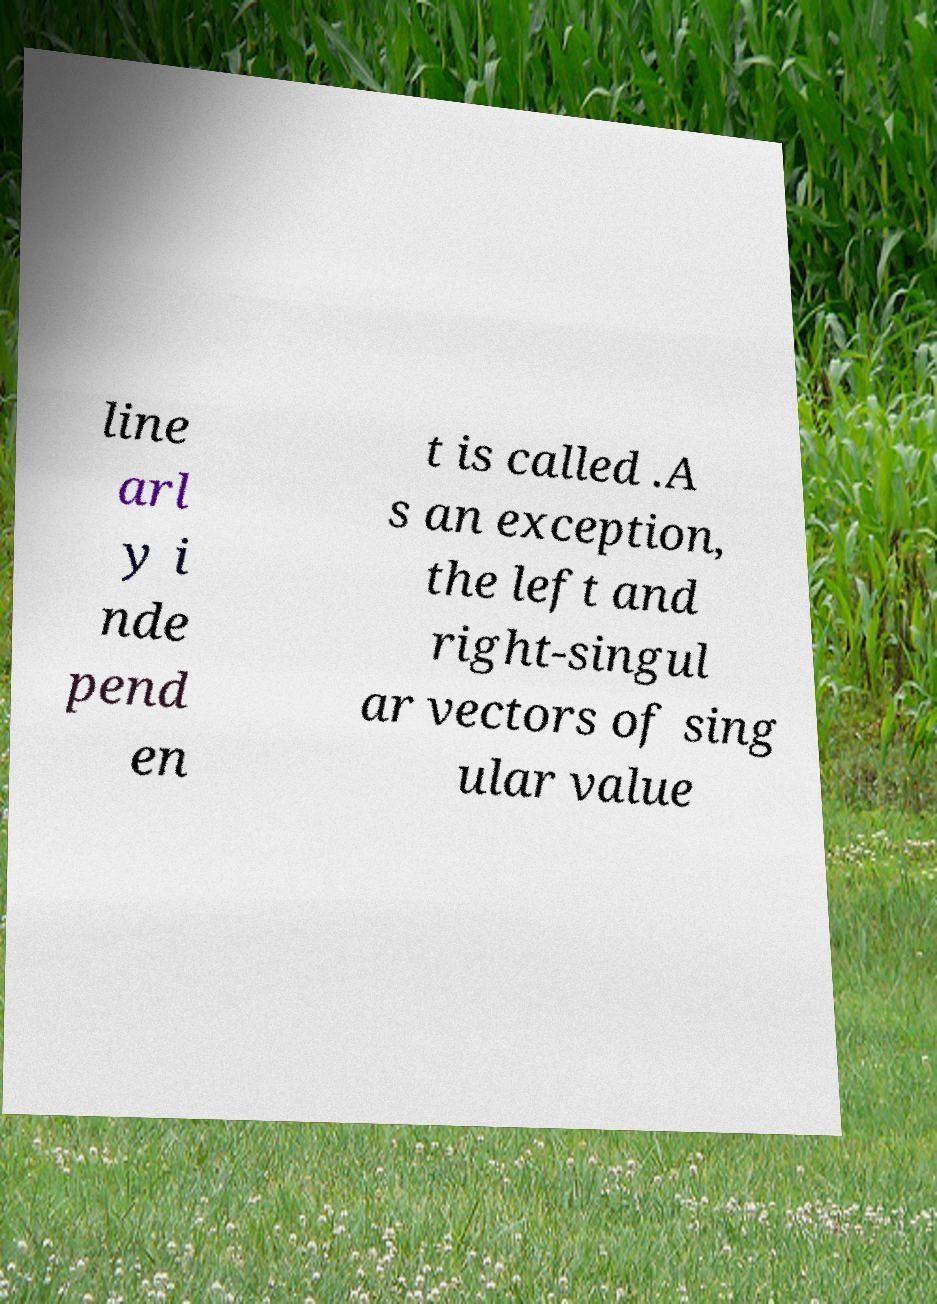Can you read and provide the text displayed in the image?This photo seems to have some interesting text. Can you extract and type it out for me? line arl y i nde pend en t is called .A s an exception, the left and right-singul ar vectors of sing ular value 